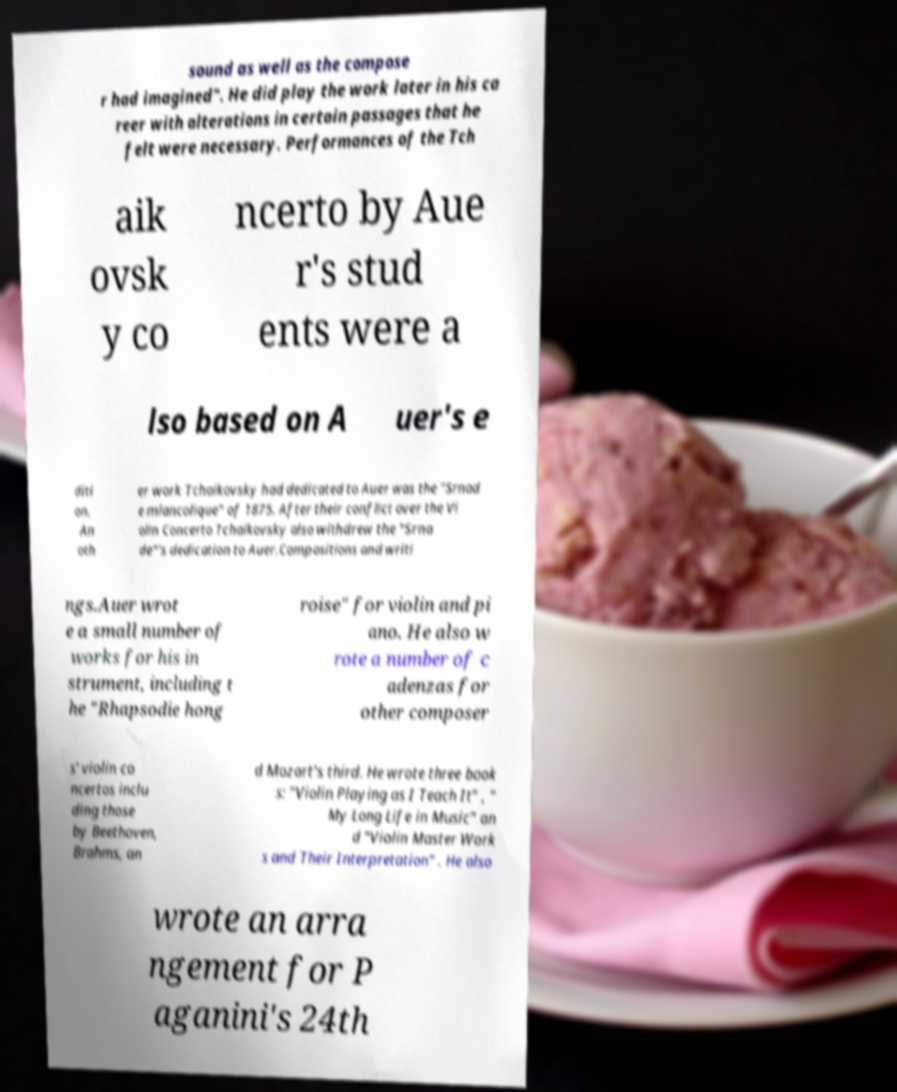Please identify and transcribe the text found in this image. sound as well as the compose r had imagined". He did play the work later in his ca reer with alterations in certain passages that he felt were necessary. Performances of the Tch aik ovsk y co ncerto by Aue r's stud ents were a lso based on A uer's e diti on. An oth er work Tchaikovsky had dedicated to Auer was the "Srnad e mlancolique" of 1875. After their conflict over the Vi olin Concerto Tchaikovsky also withdrew the "Srna de"'s dedication to Auer.Compositions and writi ngs.Auer wrot e a small number of works for his in strument, including t he "Rhapsodie hong roise" for violin and pi ano. He also w rote a number of c adenzas for other composer s' violin co ncertos inclu ding those by Beethoven, Brahms, an d Mozart's third. He wrote three book s: "Violin Playing as I Teach It" , " My Long Life in Music" an d "Violin Master Work s and Their Interpretation" . He also wrote an arra ngement for P aganini's 24th 